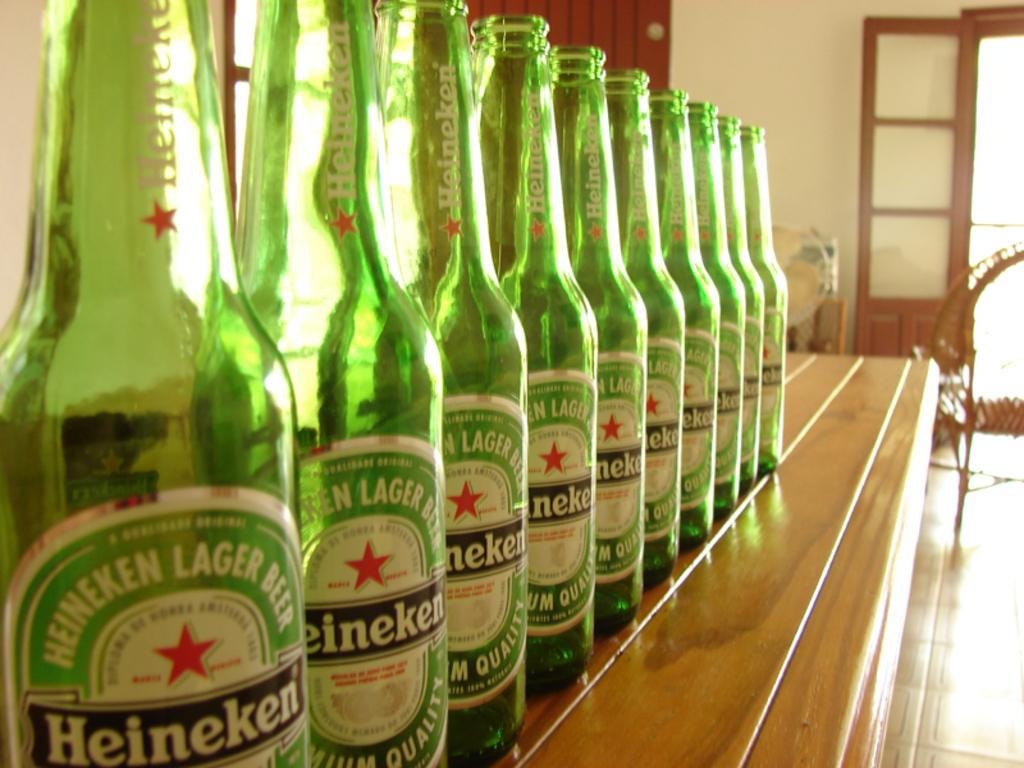Provide a one-sentence caption for the provided image. Many bottles of Heineken lager beer are lined up on a bar. 